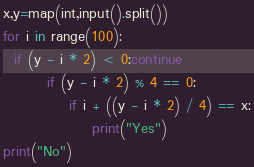<code> <loc_0><loc_0><loc_500><loc_500><_Cython_>x,y=map(int,input().split())
for i in range(100):
  if (y - i * 2) < 0:continue
		if (y - i * 2) % 4 == 0:
			if i + ((y - i * 2) / 4) == x:
				print("Yes")
print("No")</code> 